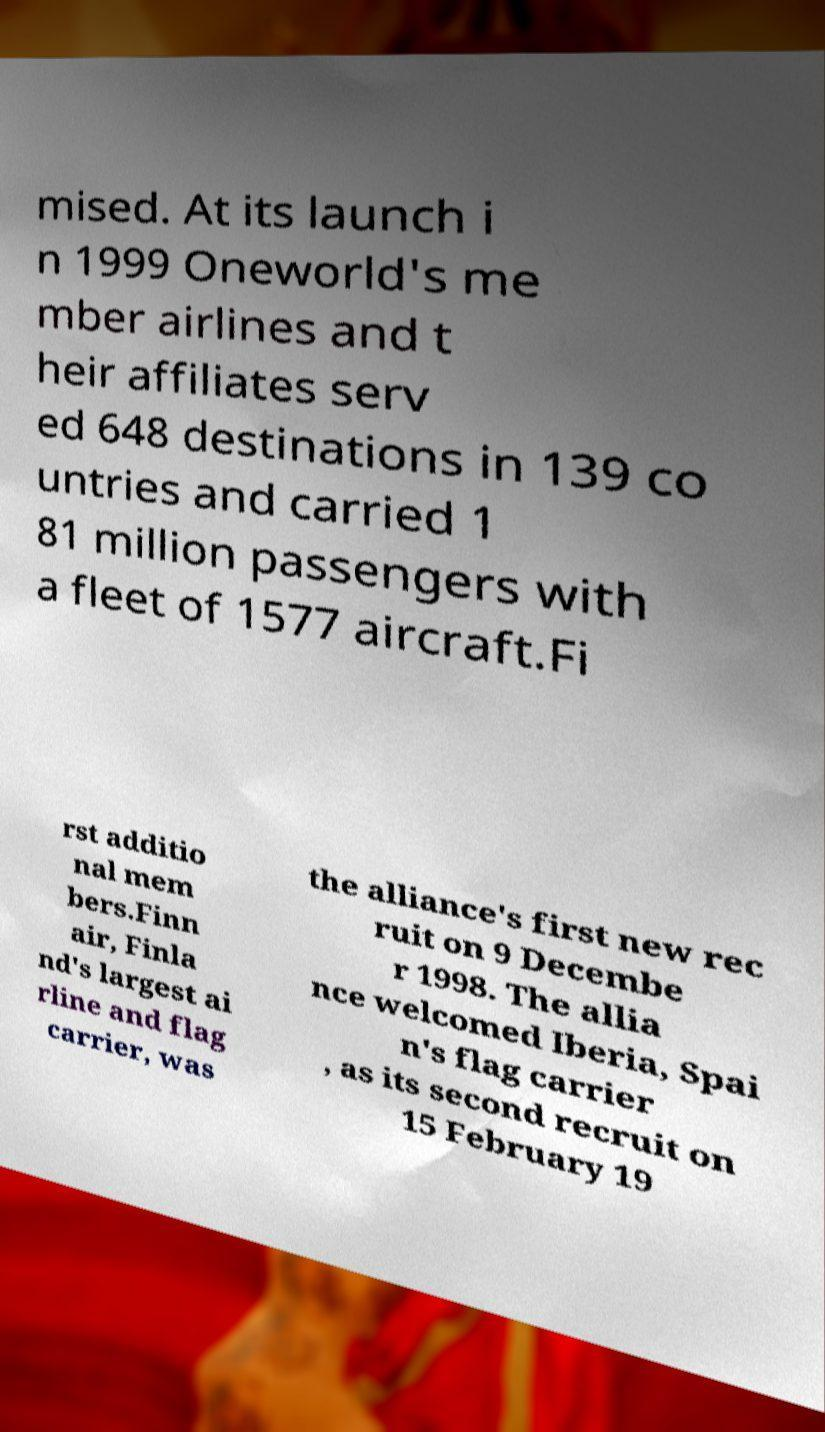Can you accurately transcribe the text from the provided image for me? mised. At its launch i n 1999 Oneworld's me mber airlines and t heir affiliates serv ed 648 destinations in 139 co untries and carried 1 81 million passengers with a fleet of 1577 aircraft.Fi rst additio nal mem bers.Finn air, Finla nd's largest ai rline and flag carrier, was the alliance's first new rec ruit on 9 Decembe r 1998. The allia nce welcomed Iberia, Spai n's flag carrier , as its second recruit on 15 February 19 